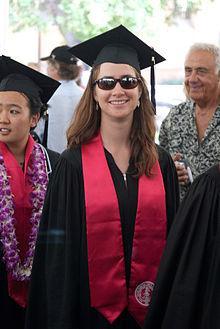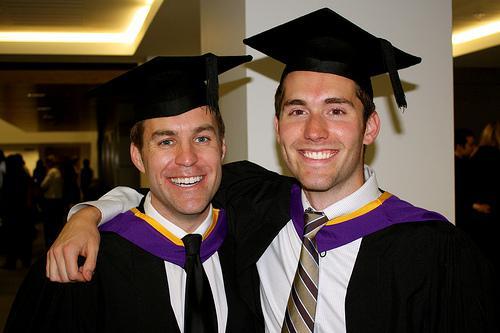The first image is the image on the left, the second image is the image on the right. Analyze the images presented: Is the assertion "There are 2 people wearing graduation caps in the image on the right." valid? Answer yes or no. Yes. The first image is the image on the left, the second image is the image on the right. Assess this claim about the two images: "The grads are wearing green around their necks.". Correct or not? Answer yes or no. No. 